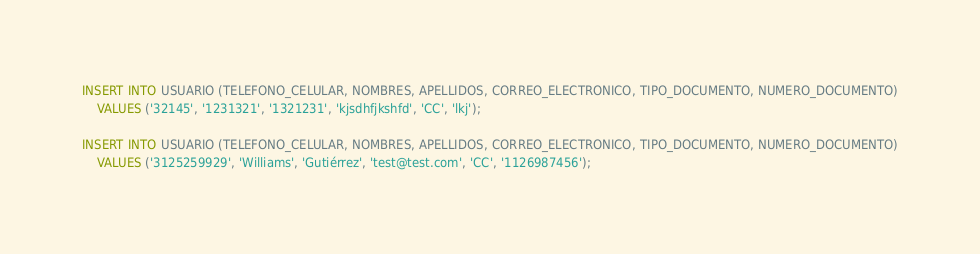<code> <loc_0><loc_0><loc_500><loc_500><_SQL_>INSERT INTO USUARIO (TELEFONO_CELULAR, NOMBRES, APELLIDOS, CORREO_ELECTRONICO, TIPO_DOCUMENTO, NUMERO_DOCUMENTO)
    VALUES ('32145', '1231321', '1321231', 'kjsdhfjkshfd', 'CC', 'lkj');

INSERT INTO USUARIO (TELEFONO_CELULAR, NOMBRES, APELLIDOS, CORREO_ELECTRONICO, TIPO_DOCUMENTO, NUMERO_DOCUMENTO)
    VALUES ('3125259929', 'Williams', 'Gutiérrez', 'test@test.com', 'CC', '1126987456');</code> 